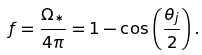<formula> <loc_0><loc_0><loc_500><loc_500>f = \frac { { \Omega } _ { * } } { 4 { \pi } } = 1 - { \cos } \left ( \frac { { \theta } _ { j } } { 2 } \right ) .</formula> 